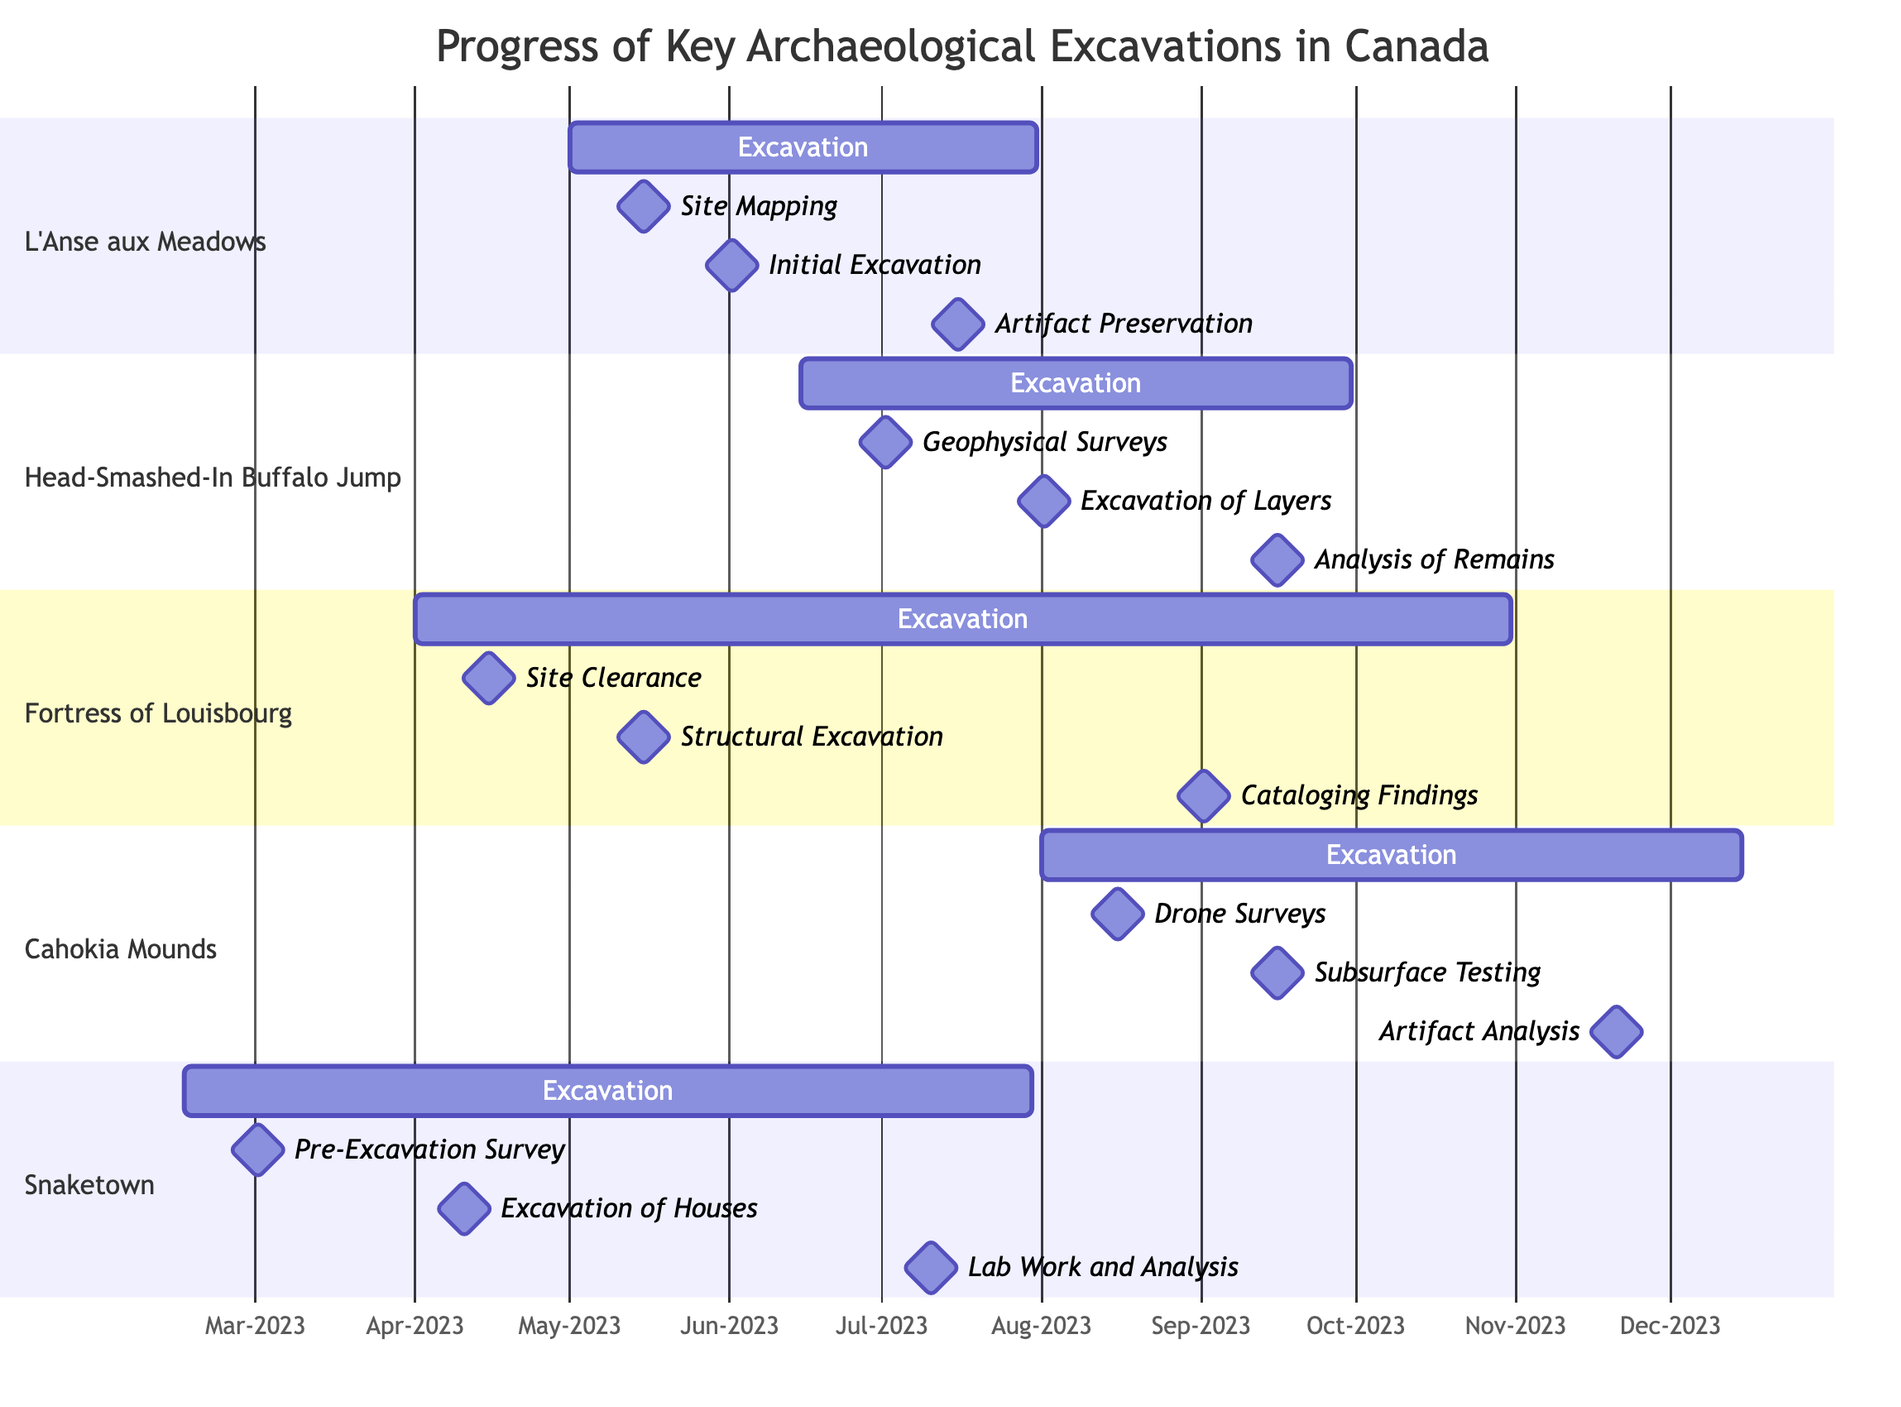What is the duration of the excavation at L'Anse aux Meadows? The excavation at L'Anse aux Meadows starts on May 1, 2023, and ends on July 31, 2023. Calculating the duration, it spans from May to July, which is three months.
Answer: Three months Which archaeological site has the latest end date? Among the archaeological excavations listed, the site with the latest end date is the Fortress of Louisbourg, which ends on October 31, 2023.
Answer: Fortress of Louisbourg When does the analysis of faunal remains occur at Head-Smashed-In Buffalo Jump? The key milestone for the analysis of faunal remains at Head-Smashed-In Buffalo Jump is scheduled for September 15, 2023.
Answer: September 15, 2023 How many key milestones are there for the Cahokia Mounds excavation? The Cahokia Mounds excavation has three key milestones: drone surveys on August 15, 2023; subsurface testing on September 15, 2023; and artifact analysis on November 20, 2023. Hence, there are three milestones.
Answer: Three milestones What activity occurs directly after the initial excavation at L'Anse aux Meadows? The initial excavation at L'Anse aux Meadows takes place on June 1, 2023. Following that, the key milestone of artifact preservation is scheduled for July 15, 2023.
Answer: Artifact preservation What is the first milestone for the Fortress of Louisbourg excavation? The first key milestone for the Fortress of Louisbourg excavation is site clearance, which takes place on April 15, 2023.
Answer: Site clearance Which two archaeological sites overlap in their excavation periods? The archaeological sites that overlap in their excavation periods are L'Anse aux Meadows, which runs from May 1 to July 31, 2023, and Head-Smashed-In Buffalo Jump, which runs from June 15 to September 30, 2023.
Answer: L'Anse aux Meadows and Head-Smashed-In Buffalo Jump What is the total number of excavations listed in the diagram? The diagram lists five archaeological excavations: L'Anse aux Meadows, Head-Smashed-In Buffalo Jump, Fortress of Louisbourg, Cahokia Mounds, and Snaketown. Therefore, the total is five.
Answer: Five What key milestone happens on August 1, 2023, at Head-Smashed-In Buffalo Jump? On August 1, 2023, the key milestone at Head-Smashed-In Buffalo Jump is the excavation of layers.
Answer: Excavation of layers 